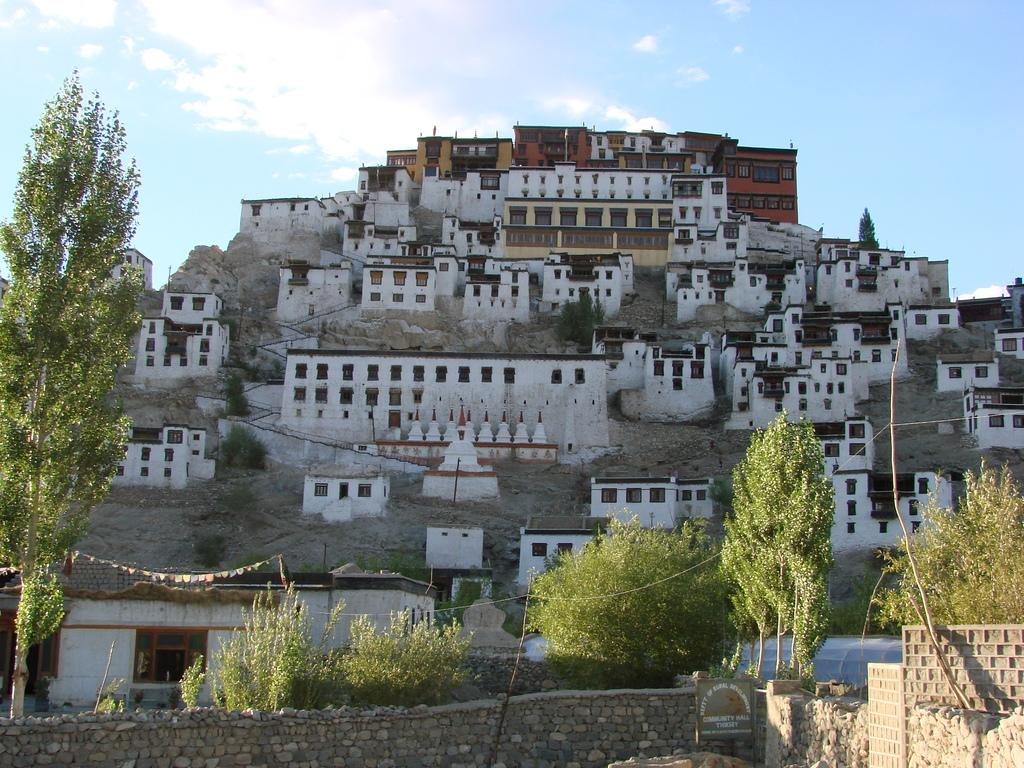What type of structure can be seen in the image? There is a stone wall in the image. What other natural elements are present in the image? There are trees in the image. Are there any man-made structures visible? Yes, there are houses in the image. What is the color of the sky in the background? The sky is blue in the background. What else can be seen in the sky? There are clouds in the sky. Where is the toad sitting on the stone wall in the image? There is no toad present in the image; it only features a stone wall, trees, houses, a blue sky, and clouds. What type of cushion is placed on the grass in the image? There is no cushion present in the image; it only features a stone wall, trees, houses, a blue sky, and clouds. 